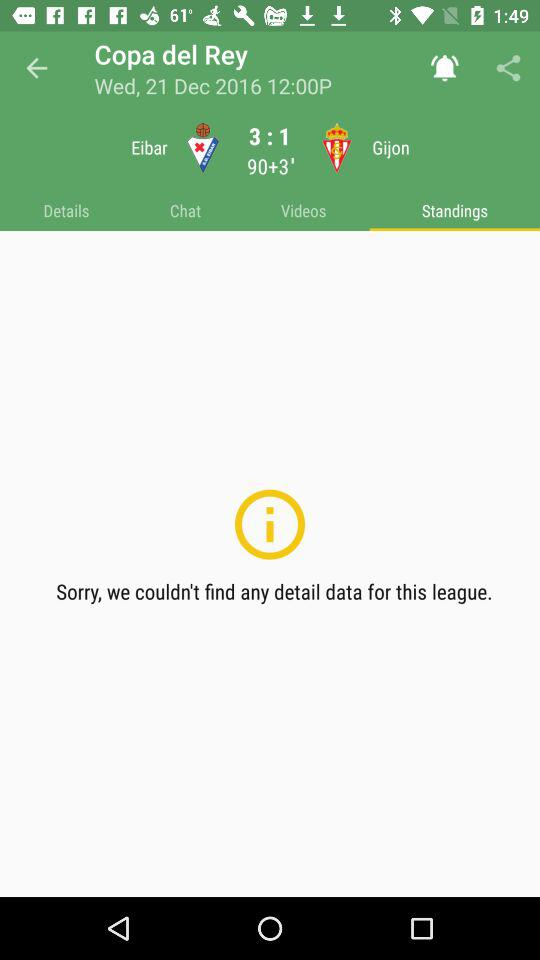What is the score for Sevilla vs SD Formentera? The score is 9:1. 